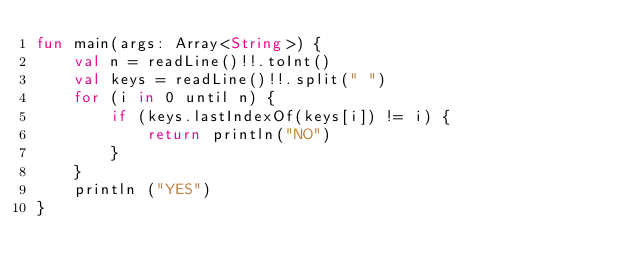Convert code to text. <code><loc_0><loc_0><loc_500><loc_500><_Kotlin_>fun main(args: Array<String>) {
    val n = readLine()!!.toInt()
    val keys = readLine()!!.split(" ")
    for (i in 0 until n) {
        if (keys.lastIndexOf(keys[i]) != i) {
            return println("NO")
        }
    }
    println ("YES")
}
</code> 